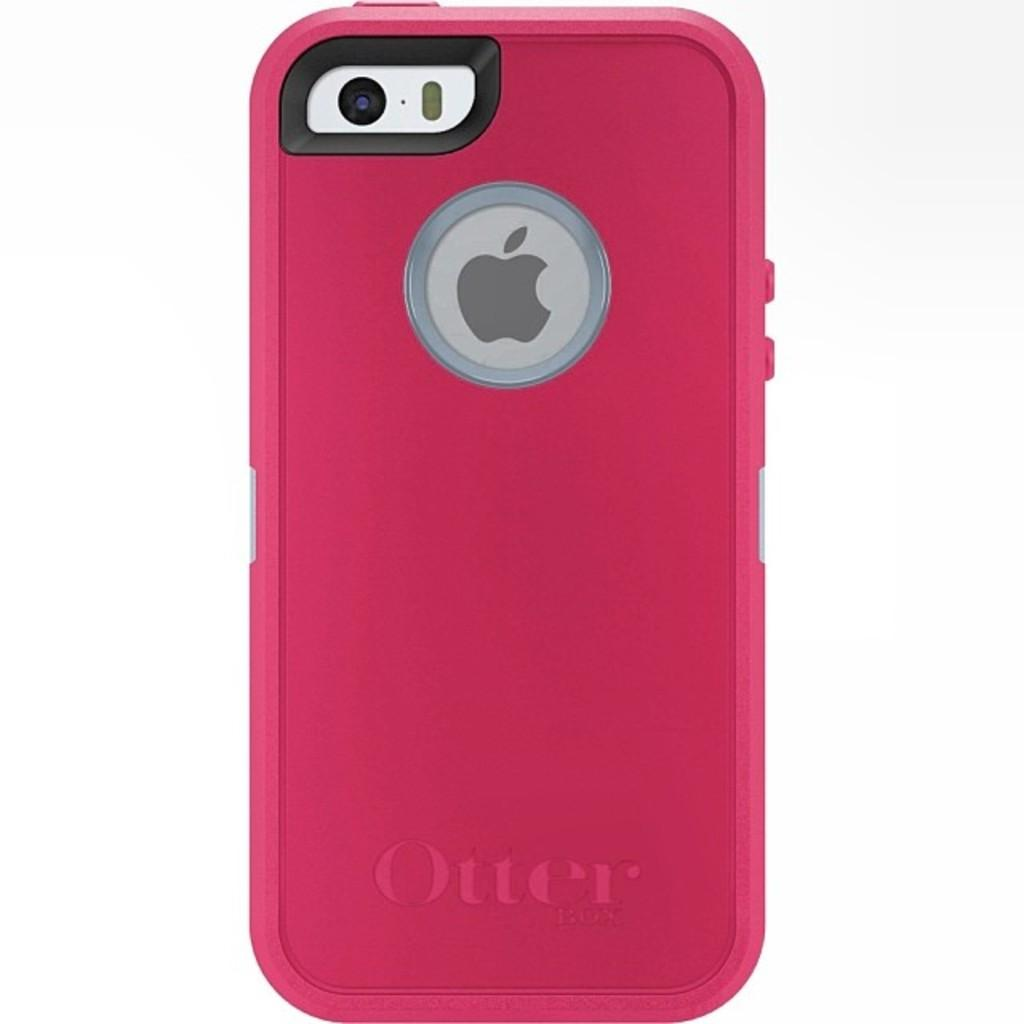What electronic device is visible in the image? There is a mobile phone in the image. What color is the back side of the mobile phone? The back side of the mobile phone is pink in color. What type of writing can be seen on the mobile phone in the image? There is no writing visible on the mobile phone in the image. How do the brothers react to the mobile phone in the image? There are no brothers present in the image, so their reaction cannot be determined. 